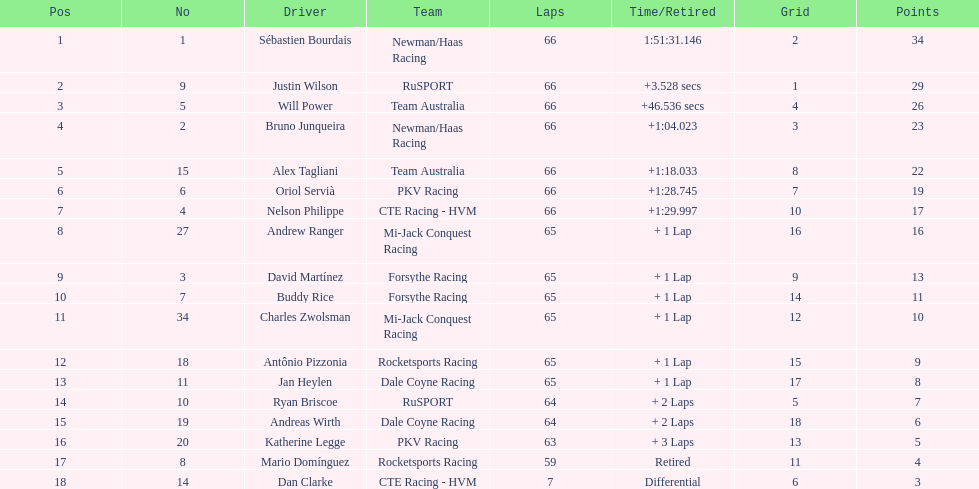Who completed immediately following the racer who ended in 1:2 Nelson Philippe. 